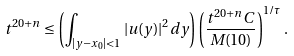<formula> <loc_0><loc_0><loc_500><loc_500>t ^ { 2 0 + n } \leq \left ( \int _ { | y - x _ { 0 } | < 1 } | u ( y ) | ^ { 2 } d y \right ) \left ( \frac { t ^ { 2 0 + n } C } { M ( 1 0 ) } \right ) ^ { 1 / \tau } .</formula> 